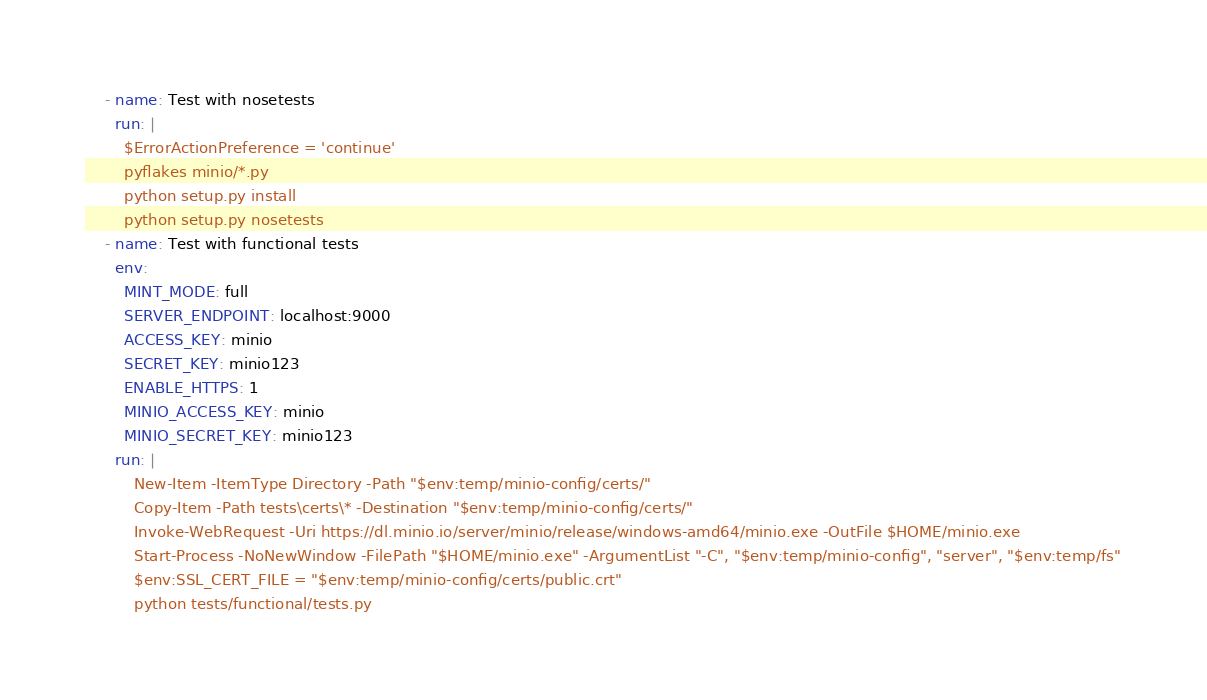Convert code to text. <code><loc_0><loc_0><loc_500><loc_500><_YAML_>    - name: Test with nosetests
      run: |
        $ErrorActionPreference = 'continue'
        pyflakes minio/*.py
        python setup.py install
        python setup.py nosetests
    - name: Test with functional tests
      env:
        MINT_MODE: full
        SERVER_ENDPOINT: localhost:9000
        ACCESS_KEY: minio
        SECRET_KEY: minio123
        ENABLE_HTTPS: 1
        MINIO_ACCESS_KEY: minio
        MINIO_SECRET_KEY: minio123
      run: |
          New-Item -ItemType Directory -Path "$env:temp/minio-config/certs/"
          Copy-Item -Path tests\certs\* -Destination "$env:temp/minio-config/certs/"
          Invoke-WebRequest -Uri https://dl.minio.io/server/minio/release/windows-amd64/minio.exe -OutFile $HOME/minio.exe
          Start-Process -NoNewWindow -FilePath "$HOME/minio.exe" -ArgumentList "-C", "$env:temp/minio-config", "server", "$env:temp/fs"
          $env:SSL_CERT_FILE = "$env:temp/minio-config/certs/public.crt"
          python tests/functional/tests.py
</code> 